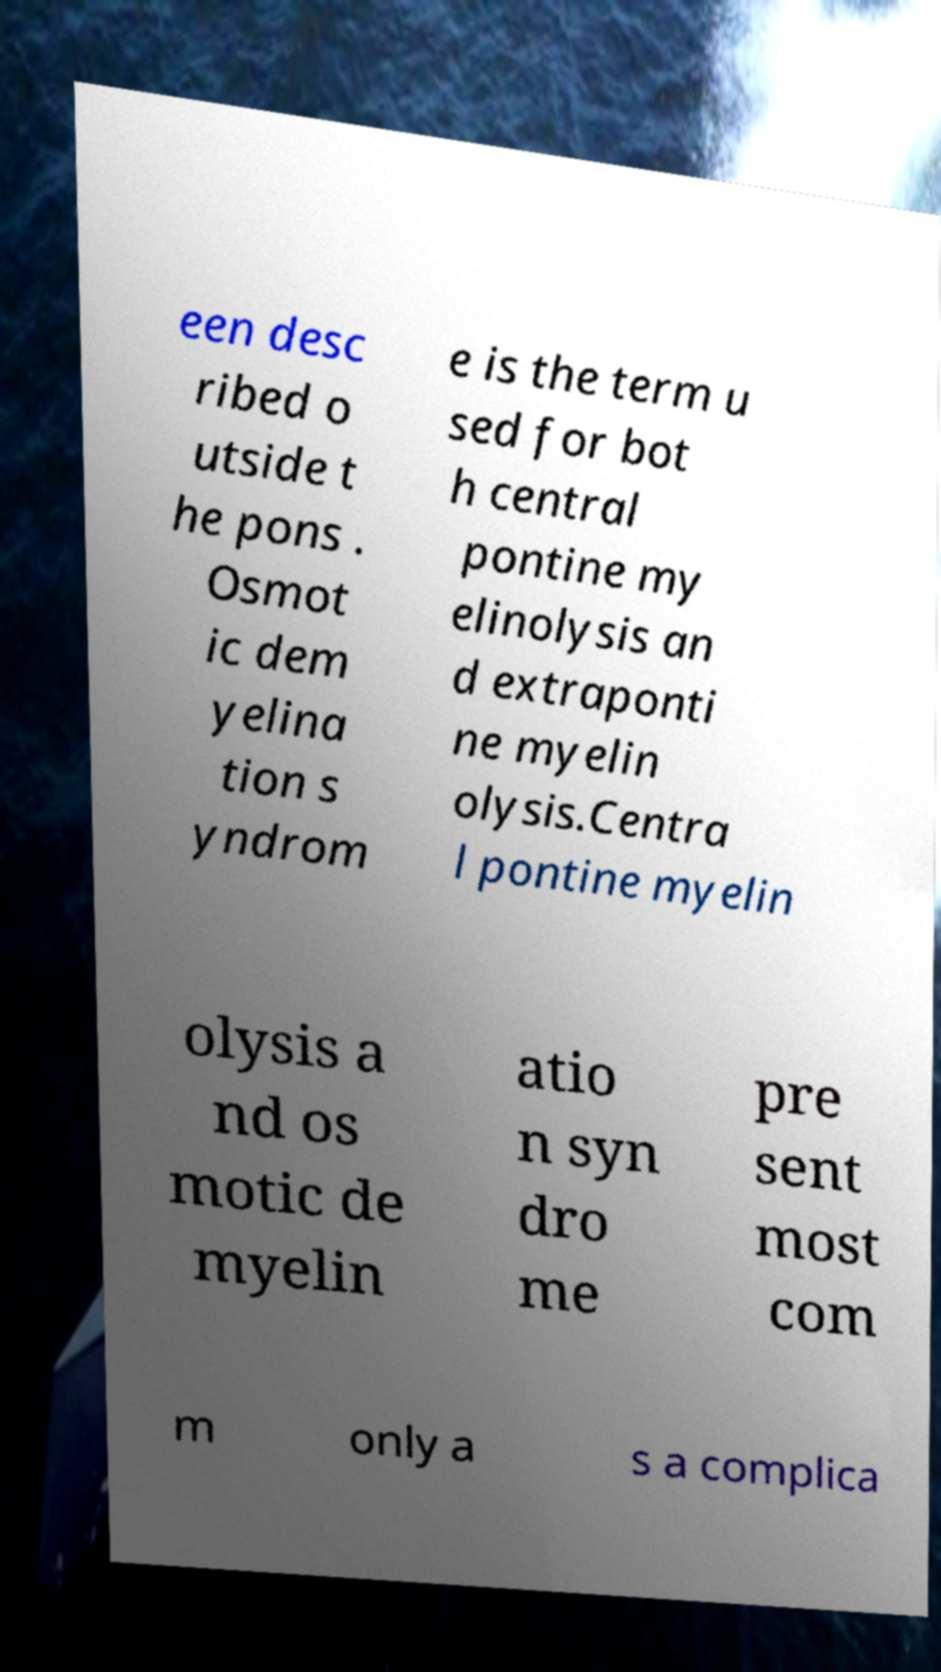Could you extract and type out the text from this image? een desc ribed o utside t he pons . Osmot ic dem yelina tion s yndrom e is the term u sed for bot h central pontine my elinolysis an d extraponti ne myelin olysis.Centra l pontine myelin olysis a nd os motic de myelin atio n syn dro me pre sent most com m only a s a complica 